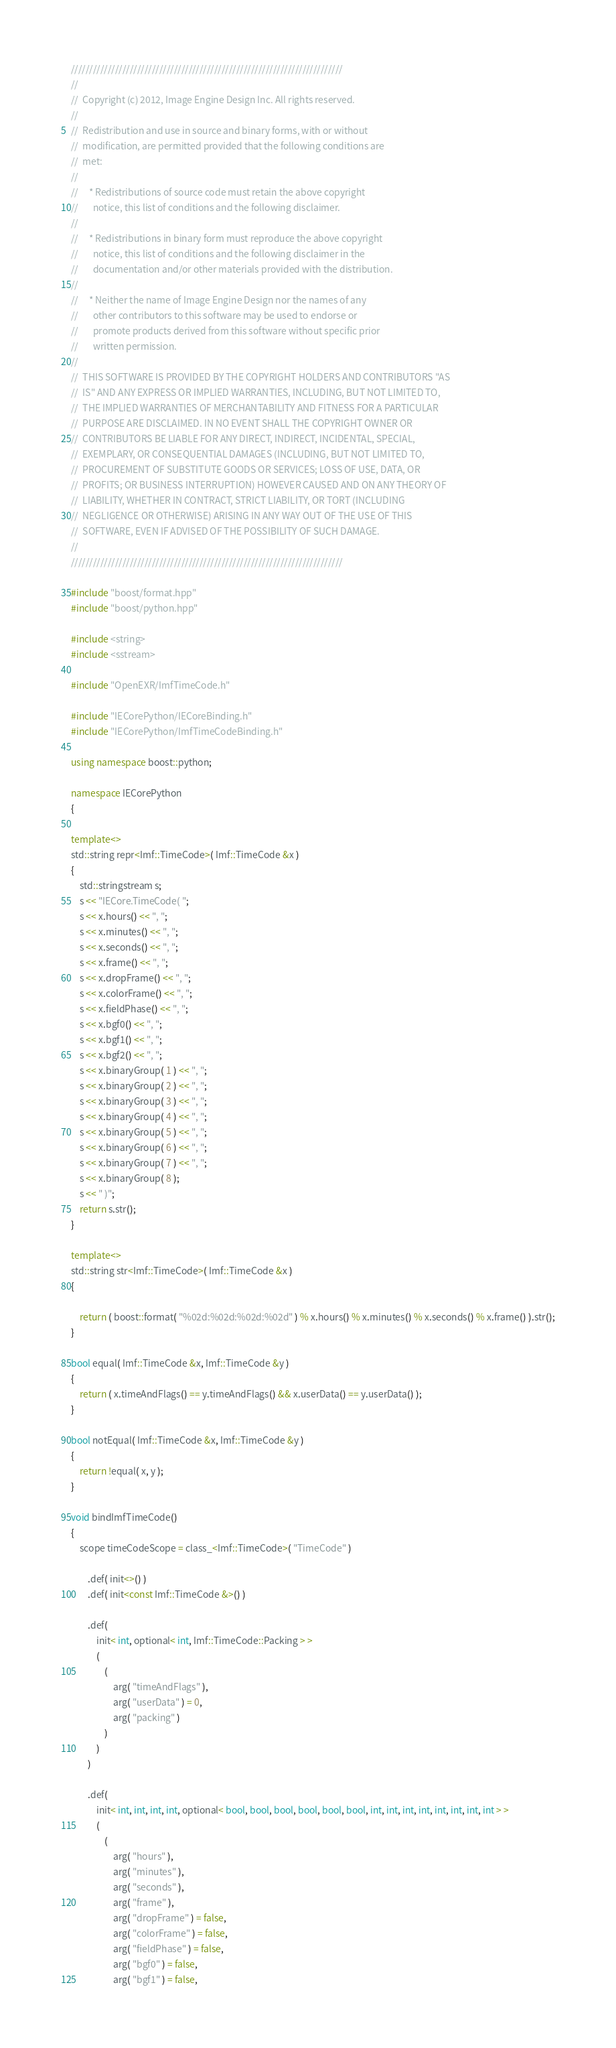<code> <loc_0><loc_0><loc_500><loc_500><_C++_>//////////////////////////////////////////////////////////////////////////
//
//  Copyright (c) 2012, Image Engine Design Inc. All rights reserved.
//
//  Redistribution and use in source and binary forms, with or without
//  modification, are permitted provided that the following conditions are
//  met:
//
//     * Redistributions of source code must retain the above copyright
//       notice, this list of conditions and the following disclaimer.
//
//     * Redistributions in binary form must reproduce the above copyright
//       notice, this list of conditions and the following disclaimer in the
//       documentation and/or other materials provided with the distribution.
//
//     * Neither the name of Image Engine Design nor the names of any
//       other contributors to this software may be used to endorse or
//       promote products derived from this software without specific prior
//       written permission.
//
//  THIS SOFTWARE IS PROVIDED BY THE COPYRIGHT HOLDERS AND CONTRIBUTORS "AS
//  IS" AND ANY EXPRESS OR IMPLIED WARRANTIES, INCLUDING, BUT NOT LIMITED TO,
//  THE IMPLIED WARRANTIES OF MERCHANTABILITY AND FITNESS FOR A PARTICULAR
//  PURPOSE ARE DISCLAIMED. IN NO EVENT SHALL THE COPYRIGHT OWNER OR
//  CONTRIBUTORS BE LIABLE FOR ANY DIRECT, INDIRECT, INCIDENTAL, SPECIAL,
//  EXEMPLARY, OR CONSEQUENTIAL DAMAGES (INCLUDING, BUT NOT LIMITED TO,
//  PROCUREMENT OF SUBSTITUTE GOODS OR SERVICES; LOSS OF USE, DATA, OR
//  PROFITS; OR BUSINESS INTERRUPTION) HOWEVER CAUSED AND ON ANY THEORY OF
//  LIABILITY, WHETHER IN CONTRACT, STRICT LIABILITY, OR TORT (INCLUDING
//  NEGLIGENCE OR OTHERWISE) ARISING IN ANY WAY OUT OF THE USE OF THIS
//  SOFTWARE, EVEN IF ADVISED OF THE POSSIBILITY OF SUCH DAMAGE.
//
//////////////////////////////////////////////////////////////////////////

#include "boost/format.hpp"
#include "boost/python.hpp"

#include <string>
#include <sstream>

#include "OpenEXR/ImfTimeCode.h"

#include "IECorePython/IECoreBinding.h"
#include "IECorePython/ImfTimeCodeBinding.h"

using namespace boost::python;

namespace IECorePython
{

template<>
std::string repr<Imf::TimeCode>( Imf::TimeCode &x )
{
	std::stringstream s;
	s << "IECore.TimeCode( ";
	s << x.hours() << ", ";
	s << x.minutes() << ", ";
	s << x.seconds() << ", ";
	s << x.frame() << ", ";
	s << x.dropFrame() << ", ";
	s << x.colorFrame() << ", ";
	s << x.fieldPhase() << ", ";
	s << x.bgf0() << ", ";
	s << x.bgf1() << ", ";
	s << x.bgf2() << ", ";
	s << x.binaryGroup( 1 ) << ", ";
	s << x.binaryGroup( 2 ) << ", ";
	s << x.binaryGroup( 3 ) << ", ";
	s << x.binaryGroup( 4 ) << ", ";
	s << x.binaryGroup( 5 ) << ", ";
	s << x.binaryGroup( 6 ) << ", ";
	s << x.binaryGroup( 7 ) << ", ";
	s << x.binaryGroup( 8 );
	s << " )";
	return s.str();
}

template<>
std::string str<Imf::TimeCode>( Imf::TimeCode &x )
{
	
	return ( boost::format( "%02d:%02d:%02d:%02d" ) % x.hours() % x.minutes() % x.seconds() % x.frame() ).str();
}

bool equal( Imf::TimeCode &x, Imf::TimeCode &y )
{
	return ( x.timeAndFlags() == y.timeAndFlags() && x.userData() == y.userData() );
}

bool notEqual( Imf::TimeCode &x, Imf::TimeCode &y )
{
	return !equal( x, y );
}

void bindImfTimeCode()
{
	scope timeCodeScope = class_<Imf::TimeCode>( "TimeCode" )
		
		.def( init<>() )
		.def( init<const Imf::TimeCode &>() )
		
		.def(
			init< int, optional< int, Imf::TimeCode::Packing > >
			(
				(
					arg( "timeAndFlags" ),
					arg( "userData" ) = 0,
					arg( "packing" )
				)
			)
		)
		
		.def(
			init< int, int, int, int, optional< bool, bool, bool, bool, bool, bool, int, int, int, int, int, int, int, int > >
			(
				(
					arg( "hours" ),
					arg( "minutes" ),
					arg( "seconds" ),
					arg( "frame" ),
					arg( "dropFrame" ) = false,
					arg( "colorFrame" ) = false,
					arg( "fieldPhase" ) = false,
					arg( "bgf0" ) = false,
					arg( "bgf1" ) = false,</code> 